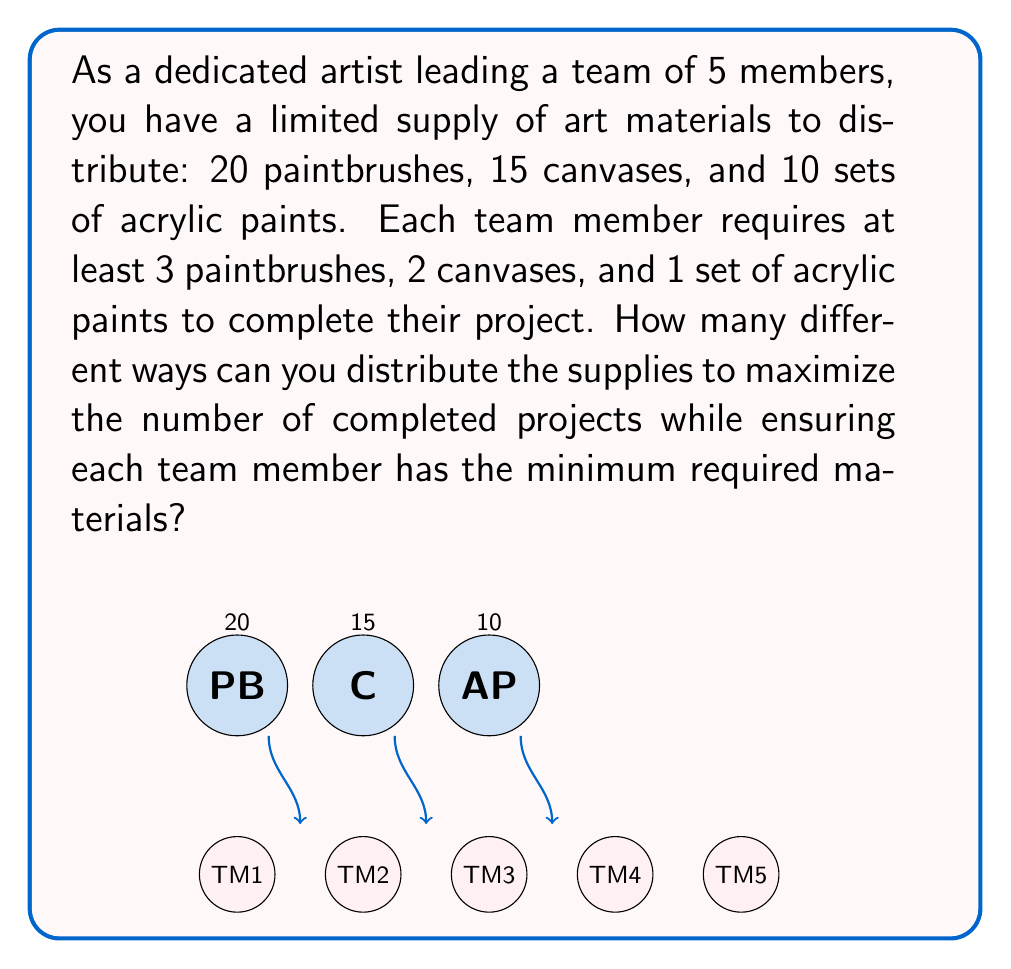Can you answer this question? Let's approach this problem step-by-step using combinatorial optimization:

1) First, we need to determine the maximum number of completed projects possible:
   - Paintbrushes: 20 ÷ 3 = 6 (remainder 2)
   - Canvases: 15 ÷ 2 = 7 (remainder 1)
   - Acrylic paints: 10 ÷ 1 = 10

   The limiting factor is paintbrushes, so the maximum number of completed projects is 6.

2) Now, we need to distribute the supplies to maximize completed projects:
   - 6 team members get 3 paintbrushes each (18 total)
   - 6 team members get 2 canvases each (12 total)
   - 6 team members get 1 set of acrylic paints each (6 total)

3) The remaining supplies are:
   - 2 paintbrushes
   - 3 canvases
   - 4 sets of acrylic paints

4) We need to distribute these remaining supplies among the 5 team members. This is where combinatorial optimization comes in.

5) For paintbrushes, we have $\binom{5}{2} = 10$ ways to distribute 2 paintbrushes to 2 out of 5 team members.

6) For canvases, we have $\binom{5}{3} = 10$ ways to distribute 3 canvases to 3 out of 5 team members.

7) For acrylic paints, we have $\binom{5}{4} = 5$ ways to distribute 4 sets to 4 out of 5 team members.

8) By the multiplication principle, the total number of ways to distribute the remaining supplies is:

   $10 \times 10 \times 5 = 500$

Therefore, there are 500 different ways to optimally distribute the supplies to maximize the number of completed projects while ensuring each team member has the minimum required materials.
Answer: 500 